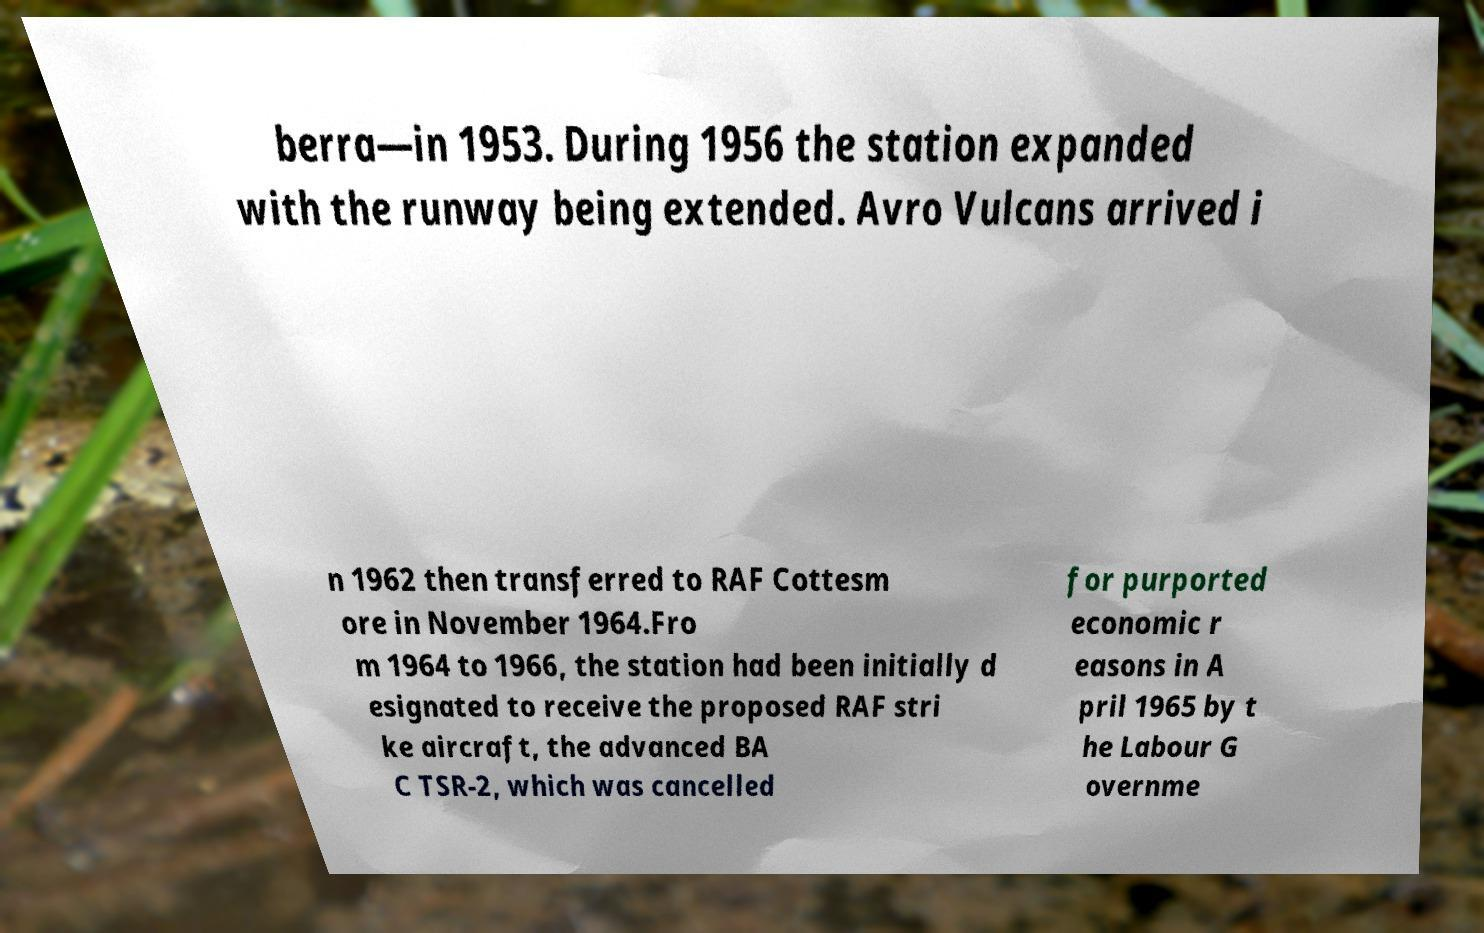Please read and relay the text visible in this image. What does it say? berra—in 1953. During 1956 the station expanded with the runway being extended. Avro Vulcans arrived i n 1962 then transferred to RAF Cottesm ore in November 1964.Fro m 1964 to 1966, the station had been initially d esignated to receive the proposed RAF stri ke aircraft, the advanced BA C TSR-2, which was cancelled for purported economic r easons in A pril 1965 by t he Labour G overnme 